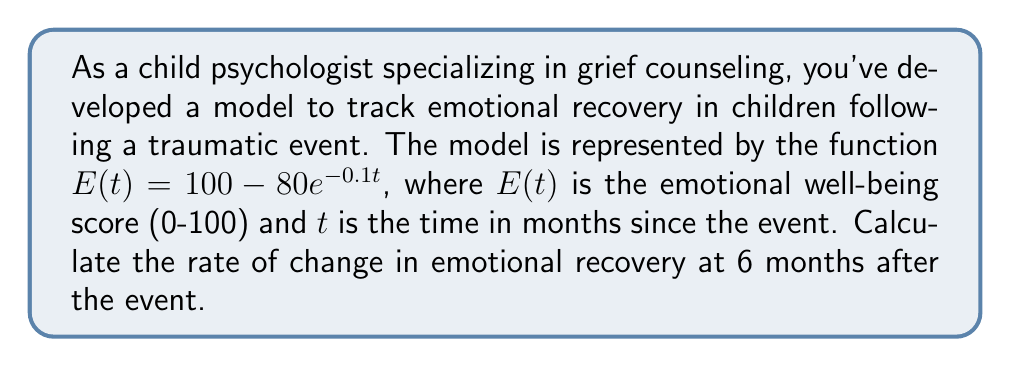Give your solution to this math problem. To find the rate of change in emotional recovery at 6 months, we need to calculate the derivative of $E(t)$ and evaluate it at $t=6$.

Step 1: Find the derivative of $E(t)$
$$\frac{d}{dt}E(t) = \frac{d}{dt}(100 - 80e^{-0.1t})$$
$$E'(t) = 0 - 80 \cdot (-0.1)e^{-0.1t}$$
$$E'(t) = 8e^{-0.1t}$$

Step 2: Evaluate $E'(t)$ at $t=6$
$$E'(6) = 8e^{-0.1(6)}$$
$$E'(6) = 8e^{-0.6}$$
$$E'(6) = 8 \cdot 0.5488$$
$$E'(6) = 4.3904$$

The rate of change at 6 months is approximately 4.3904 points per month.
Answer: $4.3904$ points/month 